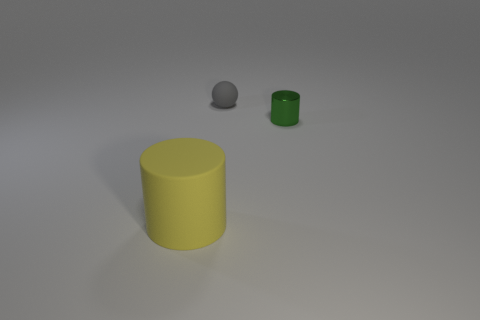Add 1 big gray rubber cubes. How many objects exist? 4 Subtract all balls. How many objects are left? 2 Subtract 0 green spheres. How many objects are left? 3 Subtract all big yellow objects. Subtract all small matte balls. How many objects are left? 1 Add 2 tiny gray rubber things. How many tiny gray rubber things are left? 3 Add 3 yellow cylinders. How many yellow cylinders exist? 4 